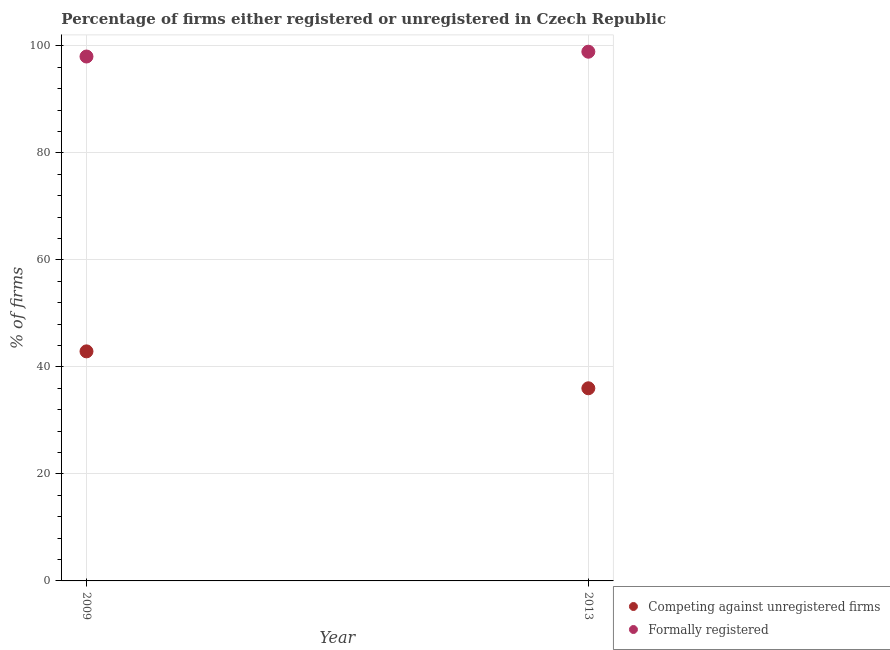Is the number of dotlines equal to the number of legend labels?
Give a very brief answer. Yes. What is the percentage of formally registered firms in 2013?
Ensure brevity in your answer.  98.9. Across all years, what is the maximum percentage of formally registered firms?
Make the answer very short. 98.9. Across all years, what is the minimum percentage of registered firms?
Offer a very short reply. 36. In which year was the percentage of registered firms maximum?
Your answer should be compact. 2009. What is the total percentage of registered firms in the graph?
Your answer should be compact. 78.9. What is the difference between the percentage of registered firms in 2009 and that in 2013?
Keep it short and to the point. 6.9. What is the difference between the percentage of registered firms in 2013 and the percentage of formally registered firms in 2009?
Your response must be concise. -62. What is the average percentage of registered firms per year?
Offer a terse response. 39.45. In the year 2013, what is the difference between the percentage of registered firms and percentage of formally registered firms?
Make the answer very short. -62.9. What is the ratio of the percentage of registered firms in 2009 to that in 2013?
Make the answer very short. 1.19. Does the percentage of registered firms monotonically increase over the years?
Offer a very short reply. No. Is the percentage of formally registered firms strictly less than the percentage of registered firms over the years?
Your answer should be compact. No. How many dotlines are there?
Ensure brevity in your answer.  2. How many years are there in the graph?
Offer a very short reply. 2. Are the values on the major ticks of Y-axis written in scientific E-notation?
Give a very brief answer. No. Does the graph contain any zero values?
Your answer should be compact. No. Does the graph contain grids?
Your answer should be very brief. Yes. Where does the legend appear in the graph?
Make the answer very short. Bottom right. How are the legend labels stacked?
Give a very brief answer. Vertical. What is the title of the graph?
Your answer should be very brief. Percentage of firms either registered or unregistered in Czech Republic. Does "Travel Items" appear as one of the legend labels in the graph?
Keep it short and to the point. No. What is the label or title of the Y-axis?
Provide a short and direct response. % of firms. What is the % of firms in Competing against unregistered firms in 2009?
Offer a terse response. 42.9. What is the % of firms of Competing against unregistered firms in 2013?
Keep it short and to the point. 36. What is the % of firms in Formally registered in 2013?
Provide a short and direct response. 98.9. Across all years, what is the maximum % of firms of Competing against unregistered firms?
Provide a succinct answer. 42.9. Across all years, what is the maximum % of firms in Formally registered?
Provide a succinct answer. 98.9. Across all years, what is the minimum % of firms of Competing against unregistered firms?
Provide a succinct answer. 36. What is the total % of firms in Competing against unregistered firms in the graph?
Offer a very short reply. 78.9. What is the total % of firms in Formally registered in the graph?
Your answer should be compact. 196.9. What is the difference between the % of firms of Formally registered in 2009 and that in 2013?
Your answer should be compact. -0.9. What is the difference between the % of firms in Competing against unregistered firms in 2009 and the % of firms in Formally registered in 2013?
Your answer should be very brief. -56. What is the average % of firms in Competing against unregistered firms per year?
Ensure brevity in your answer.  39.45. What is the average % of firms in Formally registered per year?
Provide a short and direct response. 98.45. In the year 2009, what is the difference between the % of firms of Competing against unregistered firms and % of firms of Formally registered?
Ensure brevity in your answer.  -55.1. In the year 2013, what is the difference between the % of firms in Competing against unregistered firms and % of firms in Formally registered?
Offer a very short reply. -62.9. What is the ratio of the % of firms in Competing against unregistered firms in 2009 to that in 2013?
Provide a succinct answer. 1.19. What is the ratio of the % of firms in Formally registered in 2009 to that in 2013?
Offer a terse response. 0.99. What is the difference between the highest and the second highest % of firms in Competing against unregistered firms?
Give a very brief answer. 6.9. What is the difference between the highest and the lowest % of firms of Formally registered?
Keep it short and to the point. 0.9. 